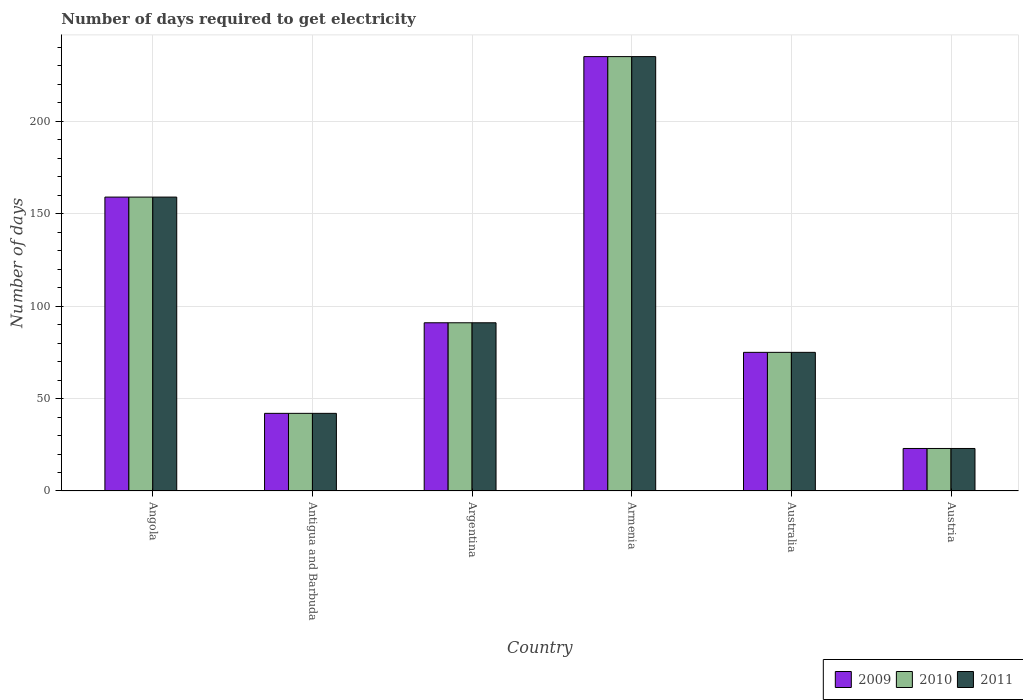How many different coloured bars are there?
Your answer should be compact. 3. How many groups of bars are there?
Offer a terse response. 6. Are the number of bars on each tick of the X-axis equal?
Keep it short and to the point. Yes. How many bars are there on the 5th tick from the left?
Provide a succinct answer. 3. What is the label of the 4th group of bars from the left?
Offer a very short reply. Armenia. In how many cases, is the number of bars for a given country not equal to the number of legend labels?
Your answer should be compact. 0. What is the number of days required to get electricity in in 2009 in Argentina?
Provide a succinct answer. 91. Across all countries, what is the maximum number of days required to get electricity in in 2011?
Your answer should be compact. 235. In which country was the number of days required to get electricity in in 2010 maximum?
Provide a short and direct response. Armenia. In which country was the number of days required to get electricity in in 2011 minimum?
Offer a terse response. Austria. What is the total number of days required to get electricity in in 2010 in the graph?
Your answer should be compact. 625. What is the difference between the number of days required to get electricity in in 2011 in Australia and that in Austria?
Give a very brief answer. 52. What is the average number of days required to get electricity in in 2011 per country?
Provide a short and direct response. 104.17. What is the difference between the number of days required to get electricity in of/in 2011 and number of days required to get electricity in of/in 2009 in Armenia?
Your response must be concise. 0. What is the ratio of the number of days required to get electricity in in 2011 in Angola to that in Argentina?
Your answer should be compact. 1.75. Is the number of days required to get electricity in in 2009 in Angola less than that in Armenia?
Provide a short and direct response. Yes. Is the difference between the number of days required to get electricity in in 2011 in Antigua and Barbuda and Armenia greater than the difference between the number of days required to get electricity in in 2009 in Antigua and Barbuda and Armenia?
Provide a succinct answer. No. What is the difference between the highest and the second highest number of days required to get electricity in in 2011?
Your answer should be very brief. -144. What is the difference between the highest and the lowest number of days required to get electricity in in 2011?
Your answer should be compact. 212. In how many countries, is the number of days required to get electricity in in 2009 greater than the average number of days required to get electricity in in 2009 taken over all countries?
Your response must be concise. 2. What does the 3rd bar from the right in Austria represents?
Provide a succinct answer. 2009. Is it the case that in every country, the sum of the number of days required to get electricity in in 2011 and number of days required to get electricity in in 2009 is greater than the number of days required to get electricity in in 2010?
Your response must be concise. Yes. How many bars are there?
Your answer should be compact. 18. Does the graph contain any zero values?
Give a very brief answer. No. Where does the legend appear in the graph?
Your answer should be very brief. Bottom right. What is the title of the graph?
Your answer should be very brief. Number of days required to get electricity. Does "1990" appear as one of the legend labels in the graph?
Give a very brief answer. No. What is the label or title of the Y-axis?
Keep it short and to the point. Number of days. What is the Number of days of 2009 in Angola?
Offer a very short reply. 159. What is the Number of days of 2010 in Angola?
Your answer should be compact. 159. What is the Number of days of 2011 in Angola?
Ensure brevity in your answer.  159. What is the Number of days of 2009 in Argentina?
Offer a terse response. 91. What is the Number of days of 2010 in Argentina?
Offer a very short reply. 91. What is the Number of days in 2011 in Argentina?
Provide a succinct answer. 91. What is the Number of days in 2009 in Armenia?
Provide a short and direct response. 235. What is the Number of days of 2010 in Armenia?
Provide a succinct answer. 235. What is the Number of days in 2011 in Armenia?
Make the answer very short. 235. What is the Number of days in 2009 in Australia?
Your answer should be very brief. 75. What is the Number of days in 2010 in Australia?
Keep it short and to the point. 75. What is the Number of days of 2009 in Austria?
Offer a very short reply. 23. What is the Number of days in 2011 in Austria?
Your answer should be very brief. 23. Across all countries, what is the maximum Number of days of 2009?
Ensure brevity in your answer.  235. Across all countries, what is the maximum Number of days of 2010?
Ensure brevity in your answer.  235. Across all countries, what is the maximum Number of days of 2011?
Offer a terse response. 235. Across all countries, what is the minimum Number of days of 2009?
Provide a short and direct response. 23. Across all countries, what is the minimum Number of days of 2010?
Keep it short and to the point. 23. What is the total Number of days in 2009 in the graph?
Provide a short and direct response. 625. What is the total Number of days in 2010 in the graph?
Offer a terse response. 625. What is the total Number of days of 2011 in the graph?
Offer a terse response. 625. What is the difference between the Number of days of 2009 in Angola and that in Antigua and Barbuda?
Your response must be concise. 117. What is the difference between the Number of days of 2010 in Angola and that in Antigua and Barbuda?
Ensure brevity in your answer.  117. What is the difference between the Number of days in 2011 in Angola and that in Antigua and Barbuda?
Provide a succinct answer. 117. What is the difference between the Number of days of 2009 in Angola and that in Armenia?
Your answer should be compact. -76. What is the difference between the Number of days in 2010 in Angola and that in Armenia?
Make the answer very short. -76. What is the difference between the Number of days of 2011 in Angola and that in Armenia?
Provide a succinct answer. -76. What is the difference between the Number of days of 2011 in Angola and that in Australia?
Offer a terse response. 84. What is the difference between the Number of days of 2009 in Angola and that in Austria?
Offer a terse response. 136. What is the difference between the Number of days of 2010 in Angola and that in Austria?
Keep it short and to the point. 136. What is the difference between the Number of days in 2011 in Angola and that in Austria?
Make the answer very short. 136. What is the difference between the Number of days in 2009 in Antigua and Barbuda and that in Argentina?
Your answer should be compact. -49. What is the difference between the Number of days of 2010 in Antigua and Barbuda and that in Argentina?
Keep it short and to the point. -49. What is the difference between the Number of days in 2011 in Antigua and Barbuda and that in Argentina?
Offer a very short reply. -49. What is the difference between the Number of days in 2009 in Antigua and Barbuda and that in Armenia?
Your response must be concise. -193. What is the difference between the Number of days in 2010 in Antigua and Barbuda and that in Armenia?
Offer a terse response. -193. What is the difference between the Number of days in 2011 in Antigua and Barbuda and that in Armenia?
Give a very brief answer. -193. What is the difference between the Number of days in 2009 in Antigua and Barbuda and that in Australia?
Ensure brevity in your answer.  -33. What is the difference between the Number of days in 2010 in Antigua and Barbuda and that in Australia?
Your answer should be very brief. -33. What is the difference between the Number of days of 2011 in Antigua and Barbuda and that in Australia?
Ensure brevity in your answer.  -33. What is the difference between the Number of days of 2011 in Antigua and Barbuda and that in Austria?
Your response must be concise. 19. What is the difference between the Number of days of 2009 in Argentina and that in Armenia?
Your answer should be very brief. -144. What is the difference between the Number of days of 2010 in Argentina and that in Armenia?
Give a very brief answer. -144. What is the difference between the Number of days of 2011 in Argentina and that in Armenia?
Make the answer very short. -144. What is the difference between the Number of days of 2010 in Argentina and that in Australia?
Provide a succinct answer. 16. What is the difference between the Number of days in 2009 in Argentina and that in Austria?
Offer a terse response. 68. What is the difference between the Number of days in 2010 in Argentina and that in Austria?
Your answer should be compact. 68. What is the difference between the Number of days in 2011 in Argentina and that in Austria?
Give a very brief answer. 68. What is the difference between the Number of days of 2009 in Armenia and that in Australia?
Provide a short and direct response. 160. What is the difference between the Number of days of 2010 in Armenia and that in Australia?
Offer a very short reply. 160. What is the difference between the Number of days in 2011 in Armenia and that in Australia?
Your answer should be compact. 160. What is the difference between the Number of days of 2009 in Armenia and that in Austria?
Ensure brevity in your answer.  212. What is the difference between the Number of days of 2010 in Armenia and that in Austria?
Offer a terse response. 212. What is the difference between the Number of days in 2011 in Armenia and that in Austria?
Make the answer very short. 212. What is the difference between the Number of days in 2010 in Australia and that in Austria?
Offer a very short reply. 52. What is the difference between the Number of days in 2009 in Angola and the Number of days in 2010 in Antigua and Barbuda?
Ensure brevity in your answer.  117. What is the difference between the Number of days in 2009 in Angola and the Number of days in 2011 in Antigua and Barbuda?
Offer a terse response. 117. What is the difference between the Number of days in 2010 in Angola and the Number of days in 2011 in Antigua and Barbuda?
Give a very brief answer. 117. What is the difference between the Number of days in 2009 in Angola and the Number of days in 2010 in Argentina?
Offer a very short reply. 68. What is the difference between the Number of days in 2010 in Angola and the Number of days in 2011 in Argentina?
Your answer should be compact. 68. What is the difference between the Number of days of 2009 in Angola and the Number of days of 2010 in Armenia?
Make the answer very short. -76. What is the difference between the Number of days in 2009 in Angola and the Number of days in 2011 in Armenia?
Ensure brevity in your answer.  -76. What is the difference between the Number of days of 2010 in Angola and the Number of days of 2011 in Armenia?
Provide a short and direct response. -76. What is the difference between the Number of days in 2009 in Angola and the Number of days in 2010 in Australia?
Make the answer very short. 84. What is the difference between the Number of days in 2010 in Angola and the Number of days in 2011 in Australia?
Give a very brief answer. 84. What is the difference between the Number of days of 2009 in Angola and the Number of days of 2010 in Austria?
Ensure brevity in your answer.  136. What is the difference between the Number of days of 2009 in Angola and the Number of days of 2011 in Austria?
Your response must be concise. 136. What is the difference between the Number of days in 2010 in Angola and the Number of days in 2011 in Austria?
Your response must be concise. 136. What is the difference between the Number of days in 2009 in Antigua and Barbuda and the Number of days in 2010 in Argentina?
Keep it short and to the point. -49. What is the difference between the Number of days in 2009 in Antigua and Barbuda and the Number of days in 2011 in Argentina?
Your response must be concise. -49. What is the difference between the Number of days in 2010 in Antigua and Barbuda and the Number of days in 2011 in Argentina?
Give a very brief answer. -49. What is the difference between the Number of days of 2009 in Antigua and Barbuda and the Number of days of 2010 in Armenia?
Your answer should be very brief. -193. What is the difference between the Number of days in 2009 in Antigua and Barbuda and the Number of days in 2011 in Armenia?
Give a very brief answer. -193. What is the difference between the Number of days of 2010 in Antigua and Barbuda and the Number of days of 2011 in Armenia?
Give a very brief answer. -193. What is the difference between the Number of days in 2009 in Antigua and Barbuda and the Number of days in 2010 in Australia?
Offer a terse response. -33. What is the difference between the Number of days in 2009 in Antigua and Barbuda and the Number of days in 2011 in Australia?
Your response must be concise. -33. What is the difference between the Number of days of 2010 in Antigua and Barbuda and the Number of days of 2011 in Australia?
Give a very brief answer. -33. What is the difference between the Number of days of 2009 in Antigua and Barbuda and the Number of days of 2011 in Austria?
Your answer should be compact. 19. What is the difference between the Number of days of 2010 in Antigua and Barbuda and the Number of days of 2011 in Austria?
Keep it short and to the point. 19. What is the difference between the Number of days of 2009 in Argentina and the Number of days of 2010 in Armenia?
Offer a very short reply. -144. What is the difference between the Number of days in 2009 in Argentina and the Number of days in 2011 in Armenia?
Your answer should be compact. -144. What is the difference between the Number of days in 2010 in Argentina and the Number of days in 2011 in Armenia?
Provide a succinct answer. -144. What is the difference between the Number of days of 2010 in Argentina and the Number of days of 2011 in Australia?
Your response must be concise. 16. What is the difference between the Number of days in 2009 in Argentina and the Number of days in 2010 in Austria?
Make the answer very short. 68. What is the difference between the Number of days in 2010 in Argentina and the Number of days in 2011 in Austria?
Give a very brief answer. 68. What is the difference between the Number of days of 2009 in Armenia and the Number of days of 2010 in Australia?
Your answer should be compact. 160. What is the difference between the Number of days in 2009 in Armenia and the Number of days in 2011 in Australia?
Offer a very short reply. 160. What is the difference between the Number of days in 2010 in Armenia and the Number of days in 2011 in Australia?
Make the answer very short. 160. What is the difference between the Number of days of 2009 in Armenia and the Number of days of 2010 in Austria?
Offer a very short reply. 212. What is the difference between the Number of days of 2009 in Armenia and the Number of days of 2011 in Austria?
Your answer should be very brief. 212. What is the difference between the Number of days in 2010 in Armenia and the Number of days in 2011 in Austria?
Your response must be concise. 212. What is the difference between the Number of days in 2009 in Australia and the Number of days in 2011 in Austria?
Provide a succinct answer. 52. What is the average Number of days of 2009 per country?
Your response must be concise. 104.17. What is the average Number of days in 2010 per country?
Provide a succinct answer. 104.17. What is the average Number of days of 2011 per country?
Your answer should be very brief. 104.17. What is the difference between the Number of days of 2009 and Number of days of 2010 in Angola?
Keep it short and to the point. 0. What is the difference between the Number of days of 2009 and Number of days of 2011 in Angola?
Your response must be concise. 0. What is the difference between the Number of days in 2009 and Number of days in 2010 in Argentina?
Offer a very short reply. 0. What is the difference between the Number of days of 2010 and Number of days of 2011 in Argentina?
Keep it short and to the point. 0. What is the difference between the Number of days of 2010 and Number of days of 2011 in Armenia?
Offer a terse response. 0. What is the difference between the Number of days of 2009 and Number of days of 2011 in Australia?
Keep it short and to the point. 0. What is the ratio of the Number of days of 2009 in Angola to that in Antigua and Barbuda?
Make the answer very short. 3.79. What is the ratio of the Number of days in 2010 in Angola to that in Antigua and Barbuda?
Offer a very short reply. 3.79. What is the ratio of the Number of days of 2011 in Angola to that in Antigua and Barbuda?
Ensure brevity in your answer.  3.79. What is the ratio of the Number of days in 2009 in Angola to that in Argentina?
Provide a succinct answer. 1.75. What is the ratio of the Number of days of 2010 in Angola to that in Argentina?
Make the answer very short. 1.75. What is the ratio of the Number of days in 2011 in Angola to that in Argentina?
Keep it short and to the point. 1.75. What is the ratio of the Number of days in 2009 in Angola to that in Armenia?
Your answer should be very brief. 0.68. What is the ratio of the Number of days in 2010 in Angola to that in Armenia?
Provide a short and direct response. 0.68. What is the ratio of the Number of days in 2011 in Angola to that in Armenia?
Make the answer very short. 0.68. What is the ratio of the Number of days in 2009 in Angola to that in Australia?
Offer a very short reply. 2.12. What is the ratio of the Number of days of 2010 in Angola to that in Australia?
Provide a short and direct response. 2.12. What is the ratio of the Number of days of 2011 in Angola to that in Australia?
Your answer should be very brief. 2.12. What is the ratio of the Number of days of 2009 in Angola to that in Austria?
Give a very brief answer. 6.91. What is the ratio of the Number of days of 2010 in Angola to that in Austria?
Offer a terse response. 6.91. What is the ratio of the Number of days of 2011 in Angola to that in Austria?
Give a very brief answer. 6.91. What is the ratio of the Number of days in 2009 in Antigua and Barbuda to that in Argentina?
Your answer should be compact. 0.46. What is the ratio of the Number of days in 2010 in Antigua and Barbuda to that in Argentina?
Make the answer very short. 0.46. What is the ratio of the Number of days in 2011 in Antigua and Barbuda to that in Argentina?
Keep it short and to the point. 0.46. What is the ratio of the Number of days in 2009 in Antigua and Barbuda to that in Armenia?
Provide a short and direct response. 0.18. What is the ratio of the Number of days in 2010 in Antigua and Barbuda to that in Armenia?
Offer a very short reply. 0.18. What is the ratio of the Number of days of 2011 in Antigua and Barbuda to that in Armenia?
Ensure brevity in your answer.  0.18. What is the ratio of the Number of days of 2009 in Antigua and Barbuda to that in Australia?
Keep it short and to the point. 0.56. What is the ratio of the Number of days in 2010 in Antigua and Barbuda to that in Australia?
Offer a very short reply. 0.56. What is the ratio of the Number of days in 2011 in Antigua and Barbuda to that in Australia?
Make the answer very short. 0.56. What is the ratio of the Number of days in 2009 in Antigua and Barbuda to that in Austria?
Give a very brief answer. 1.83. What is the ratio of the Number of days of 2010 in Antigua and Barbuda to that in Austria?
Your response must be concise. 1.83. What is the ratio of the Number of days in 2011 in Antigua and Barbuda to that in Austria?
Your answer should be compact. 1.83. What is the ratio of the Number of days of 2009 in Argentina to that in Armenia?
Ensure brevity in your answer.  0.39. What is the ratio of the Number of days of 2010 in Argentina to that in Armenia?
Make the answer very short. 0.39. What is the ratio of the Number of days of 2011 in Argentina to that in Armenia?
Your response must be concise. 0.39. What is the ratio of the Number of days in 2009 in Argentina to that in Australia?
Your answer should be very brief. 1.21. What is the ratio of the Number of days in 2010 in Argentina to that in Australia?
Offer a terse response. 1.21. What is the ratio of the Number of days in 2011 in Argentina to that in Australia?
Your answer should be compact. 1.21. What is the ratio of the Number of days of 2009 in Argentina to that in Austria?
Provide a succinct answer. 3.96. What is the ratio of the Number of days in 2010 in Argentina to that in Austria?
Offer a very short reply. 3.96. What is the ratio of the Number of days of 2011 in Argentina to that in Austria?
Ensure brevity in your answer.  3.96. What is the ratio of the Number of days in 2009 in Armenia to that in Australia?
Ensure brevity in your answer.  3.13. What is the ratio of the Number of days of 2010 in Armenia to that in Australia?
Offer a very short reply. 3.13. What is the ratio of the Number of days of 2011 in Armenia to that in Australia?
Make the answer very short. 3.13. What is the ratio of the Number of days of 2009 in Armenia to that in Austria?
Provide a succinct answer. 10.22. What is the ratio of the Number of days in 2010 in Armenia to that in Austria?
Provide a succinct answer. 10.22. What is the ratio of the Number of days of 2011 in Armenia to that in Austria?
Provide a short and direct response. 10.22. What is the ratio of the Number of days in 2009 in Australia to that in Austria?
Your answer should be compact. 3.26. What is the ratio of the Number of days in 2010 in Australia to that in Austria?
Your answer should be very brief. 3.26. What is the ratio of the Number of days of 2011 in Australia to that in Austria?
Ensure brevity in your answer.  3.26. What is the difference between the highest and the lowest Number of days of 2009?
Provide a short and direct response. 212. What is the difference between the highest and the lowest Number of days of 2010?
Offer a very short reply. 212. What is the difference between the highest and the lowest Number of days of 2011?
Make the answer very short. 212. 